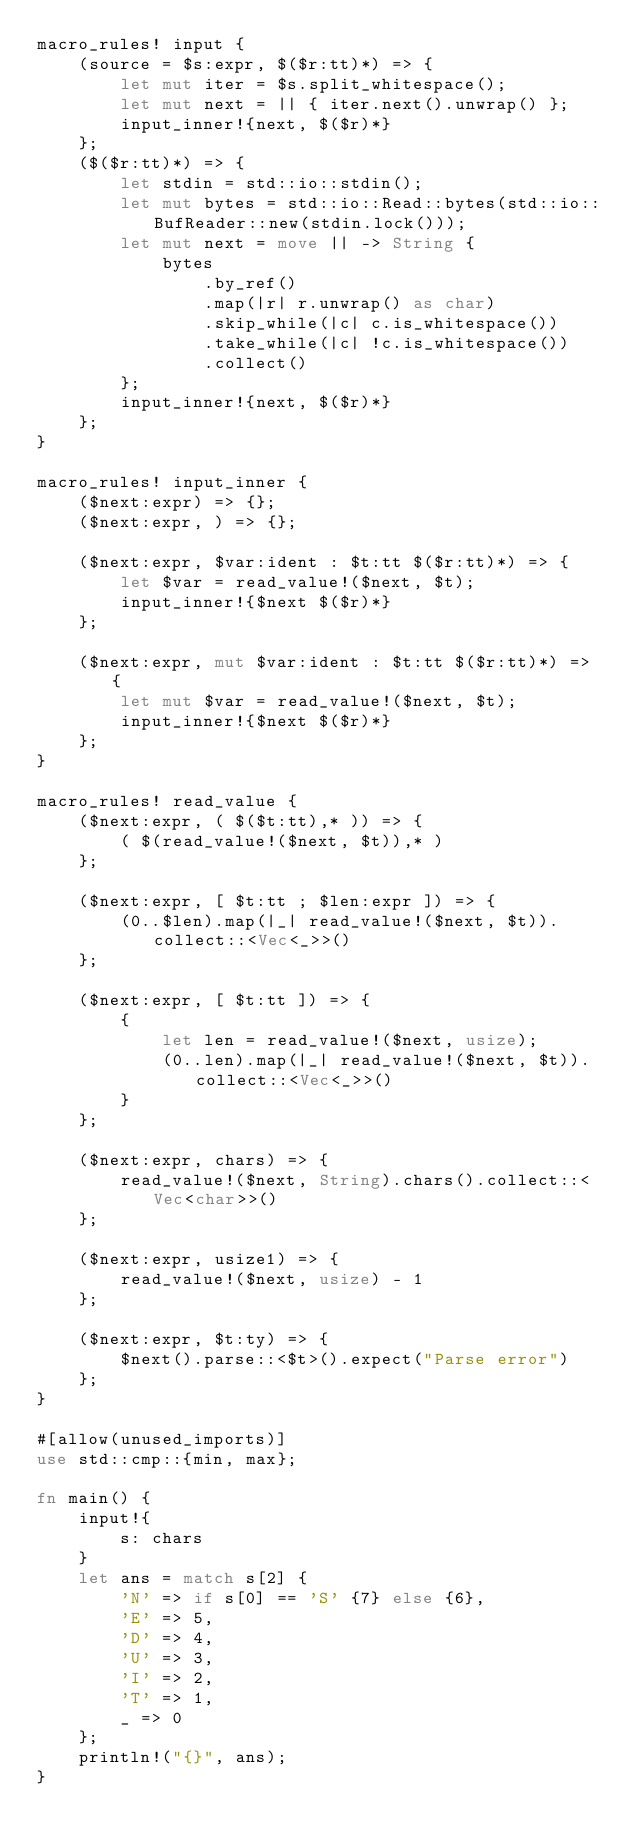<code> <loc_0><loc_0><loc_500><loc_500><_Rust_>macro_rules! input {
    (source = $s:expr, $($r:tt)*) => {
        let mut iter = $s.split_whitespace();
        let mut next = || { iter.next().unwrap() };
        input_inner!{next, $($r)*}
    };
    ($($r:tt)*) => {
        let stdin = std::io::stdin();
        let mut bytes = std::io::Read::bytes(std::io::BufReader::new(stdin.lock()));
        let mut next = move || -> String {
            bytes
                .by_ref()
                .map(|r| r.unwrap() as char)
                .skip_while(|c| c.is_whitespace())
                .take_while(|c| !c.is_whitespace())
                .collect()
        };
        input_inner!{next, $($r)*}
    };
}

macro_rules! input_inner {
    ($next:expr) => {};
    ($next:expr, ) => {};

    ($next:expr, $var:ident : $t:tt $($r:tt)*) => {
        let $var = read_value!($next, $t);
        input_inner!{$next $($r)*}
    };

    ($next:expr, mut $var:ident : $t:tt $($r:tt)*) => {
        let mut $var = read_value!($next, $t);
        input_inner!{$next $($r)*}
    };
}

macro_rules! read_value {
    ($next:expr, ( $($t:tt),* )) => {
        ( $(read_value!($next, $t)),* )
    };

    ($next:expr, [ $t:tt ; $len:expr ]) => {
        (0..$len).map(|_| read_value!($next, $t)).collect::<Vec<_>>()
    };

    ($next:expr, [ $t:tt ]) => {
        {
            let len = read_value!($next, usize);
            (0..len).map(|_| read_value!($next, $t)).collect::<Vec<_>>()
        }
    };

    ($next:expr, chars) => {
        read_value!($next, String).chars().collect::<Vec<char>>()
    };

    ($next:expr, usize1) => {
        read_value!($next, usize) - 1
    };

    ($next:expr, $t:ty) => {
        $next().parse::<$t>().expect("Parse error")
    };
}

#[allow(unused_imports)]
use std::cmp::{min, max};

fn main() {
    input!{
        s: chars
    }
    let ans = match s[2] {
        'N' => if s[0] == 'S' {7} else {6},
        'E' => 5,
        'D' => 4,
        'U' => 3,
        'I' => 2,
        'T' => 1,
        _ => 0
    };
    println!("{}", ans);
}
</code> 